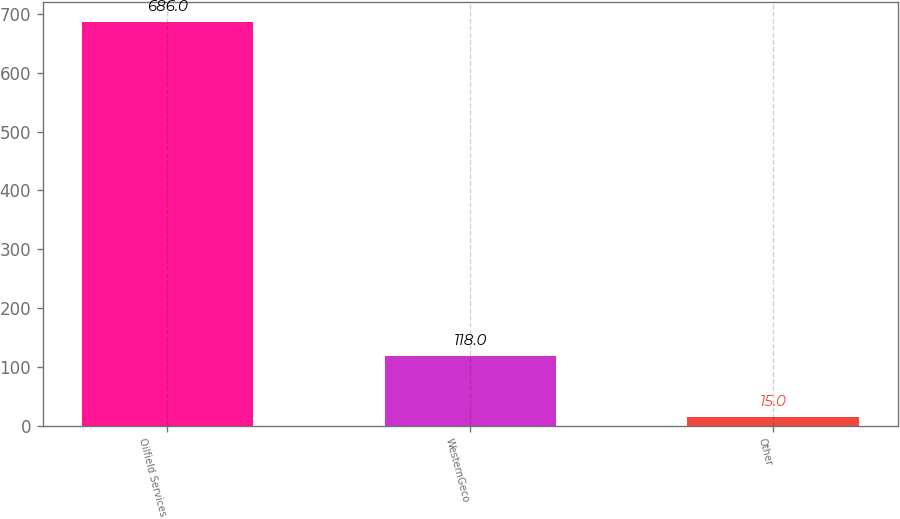Convert chart. <chart><loc_0><loc_0><loc_500><loc_500><bar_chart><fcel>Oilfield Services<fcel>WesternGeco<fcel>Other<nl><fcel>686<fcel>118<fcel>15<nl></chart> 